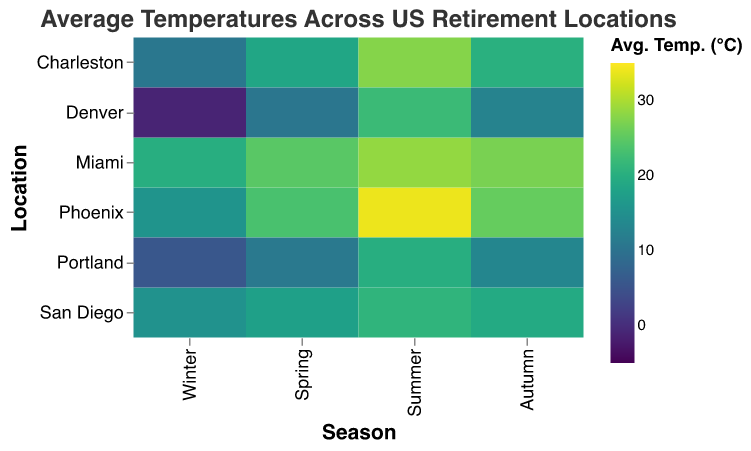What is the highest average temperature recorded in this heatmap? Look at the "Avg. Temp. (°C)" legend for the darkest color, which corresponds to the highest temperature. Find the matching cell in the heatmap. The highest temperature is 33.9°C, recorded in Phoenix during Summer.
Answer: 33.9°C Which location has the coldest winter? Find the Winter column and look for the cell with the lightest color, which corresponds to the lowest temperature. Denver has the coldest winter with -1.1°C.
Answer: Denver What is the average temperature in Miami during Spring? Locate the cell corresponding to Miami in the row and Spring in the column. The cell value for Miami in Spring is 24.7°C.
Answer: 24.7°C Which season shows the most variation in average temperatures across all locations? Look across each column (Season) to see the range of colors, which represent the temperature variation. Summer shows the most variation due to the wide range of colors from light to dark.
Answer: Summer Compare the average temperatures of San Diego and Charleston in Autumn. Which one is warmer? Find the cells for San Diego and Charleston in the Autumn column. San Diego has 19.4°C while Charleston has 20.3°C, so Charleston is warmer.
Answer: Charleston How much warmer is Phoenix in Summer compared to Winter? Find the temperatures for Phoenix in both Summer (33.9°C) and Winter (15.6°C). Subtract the Winter temperature from the Summer temperature to find the difference: 33.9 - 15.6 = 18.3°C.
Answer: 18.3°C Rank the locations from coolest to warmest during Spring. Locate the Spring column and list the temperatures for each location: 
   - Denver: 10.6°C
   - Portland: 11.1°C
   - San Diego: 17.7°C
   - Charleston: 18.6°C
   - Miami: 24.7°C
   - Phoenix: 23.5°C
  Sort these values from lowest to highest.
Answer: Denver, Portland, San Diego, Charleston, Phoenix, Miami Which location has more stable temperatures across all seasons? Identify the location with the least color variation across its row. San Diego shows the least variation in colors, indicating more stable temperatures.
Answer: San Diego What is the average temperature in Portland across all seasons? Sum the average temperatures of Portland for all seasons (5.8 + 11.1 + 20.0 + 13.3) and divide by 4: (5.8 + 11.1 + 20.0 + 13.3) / 4 = 12.55°C.
Answer: 12.55°C 